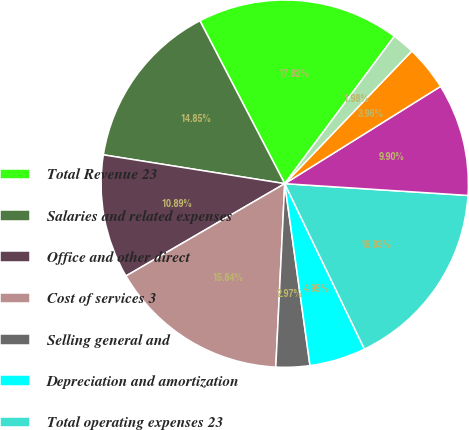<chart> <loc_0><loc_0><loc_500><loc_500><pie_chart><fcel>Total Revenue 23<fcel>Salaries and related expenses<fcel>Office and other direct<fcel>Cost of services 3<fcel>Selling general and<fcel>Depreciation and amortization<fcel>Total operating expenses 23<fcel>Operating income 2<fcel>Provision for income taxes 24<fcel>Basic 26<nl><fcel>17.82%<fcel>14.85%<fcel>10.89%<fcel>15.84%<fcel>2.97%<fcel>4.95%<fcel>16.83%<fcel>9.9%<fcel>3.96%<fcel>1.98%<nl></chart> 